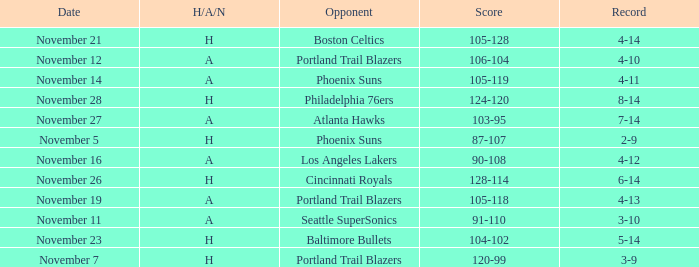On what Date was the Score 105-118 and the H/A/N A? November 19. 